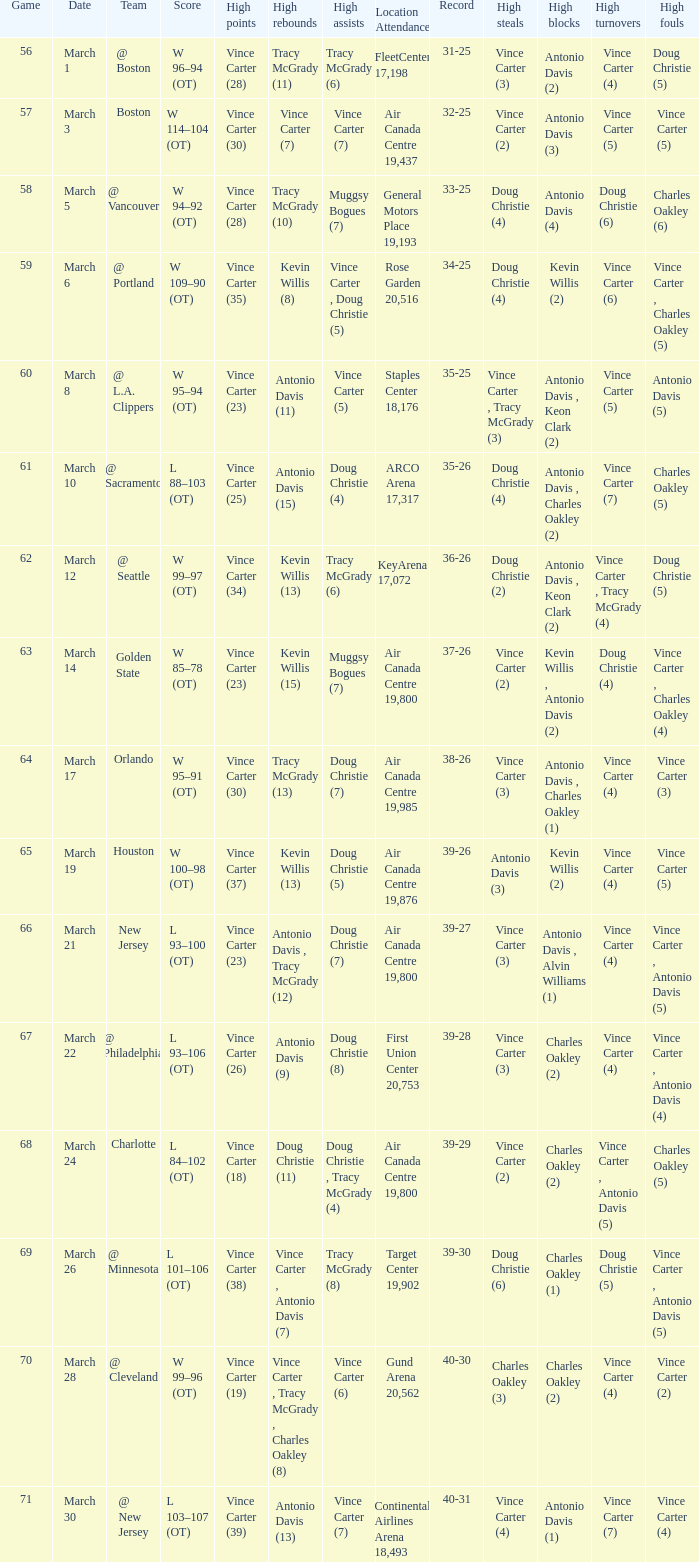Who was the high rebounder against charlotte? Doug Christie (11). 